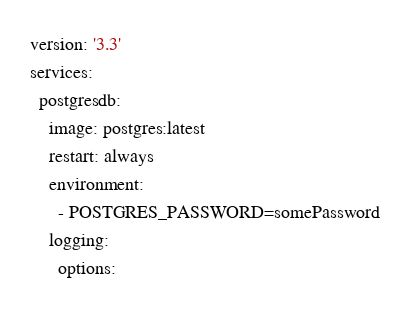<code> <loc_0><loc_0><loc_500><loc_500><_YAML_>version: '3.3'
services:
  postgresdb:
    image: postgres:latest
    restart: always
    environment:
      - POSTGRES_PASSWORD=somePassword
    logging:
      options:</code> 